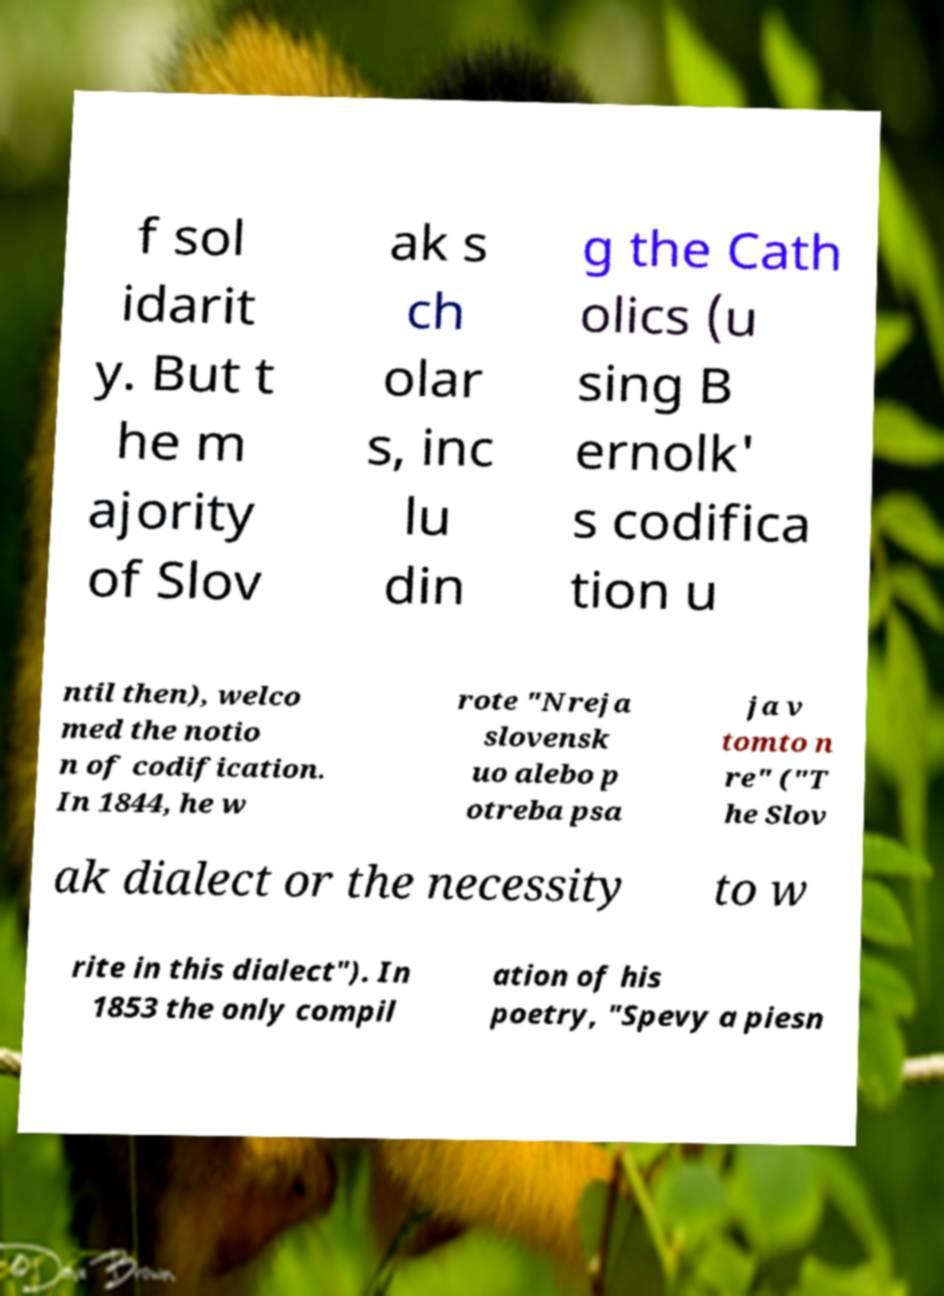Please read and relay the text visible in this image. What does it say? f sol idarit y. But t he m ajority of Slov ak s ch olar s, inc lu din g the Cath olics (u sing B ernolk' s codifica tion u ntil then), welco med the notio n of codification. In 1844, he w rote "Nreja slovensk uo alebo p otreba psa ja v tomto n re" ("T he Slov ak dialect or the necessity to w rite in this dialect"). In 1853 the only compil ation of his poetry, "Spevy a piesn 